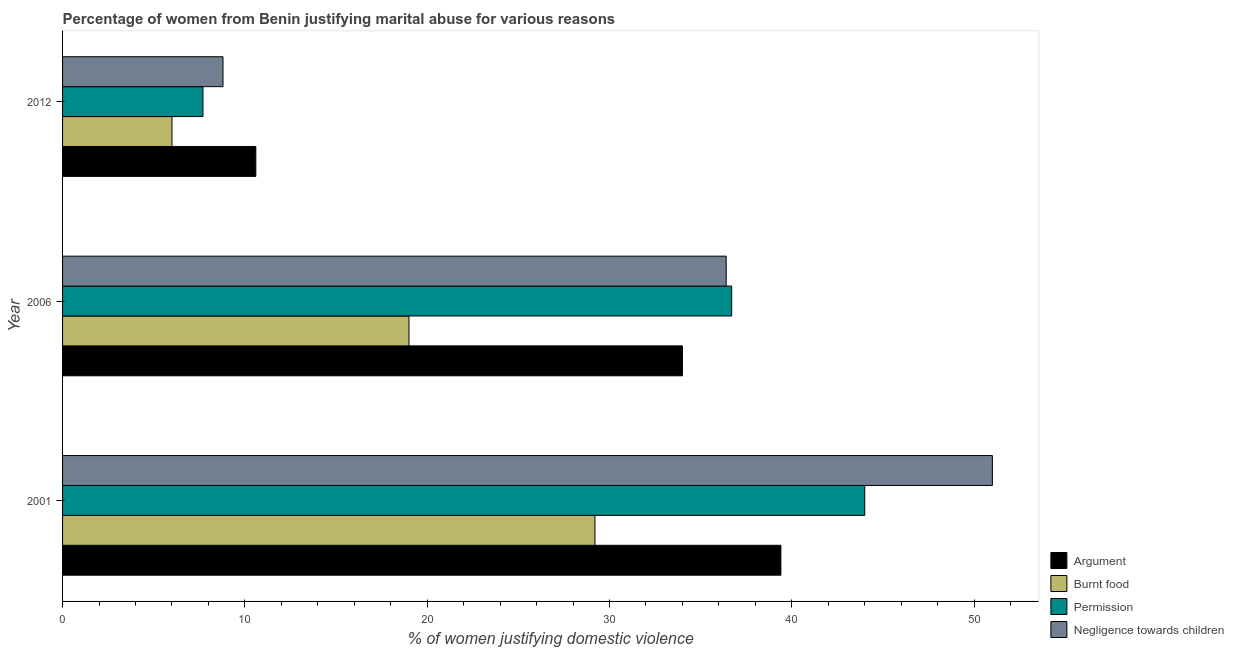How many different coloured bars are there?
Offer a terse response. 4. Are the number of bars on each tick of the Y-axis equal?
Ensure brevity in your answer.  Yes. How many bars are there on the 1st tick from the top?
Ensure brevity in your answer.  4. In how many cases, is the number of bars for a given year not equal to the number of legend labels?
Your response must be concise. 0. What is the percentage of women justifying abuse for going without permission in 2001?
Ensure brevity in your answer.  44. Across all years, what is the maximum percentage of women justifying abuse in the case of an argument?
Make the answer very short. 39.4. In which year was the percentage of women justifying abuse for showing negligence towards children minimum?
Keep it short and to the point. 2012. What is the total percentage of women justifying abuse for burning food in the graph?
Offer a terse response. 54.2. What is the difference between the percentage of women justifying abuse for going without permission in 2001 and that in 2012?
Provide a short and direct response. 36.3. What is the difference between the percentage of women justifying abuse for going without permission in 2001 and the percentage of women justifying abuse for showing negligence towards children in 2012?
Provide a short and direct response. 35.2. What is the average percentage of women justifying abuse for showing negligence towards children per year?
Your answer should be compact. 32.07. In how many years, is the percentage of women justifying abuse in the case of an argument greater than 38 %?
Provide a succinct answer. 1. What is the ratio of the percentage of women justifying abuse for burning food in 2001 to that in 2006?
Your response must be concise. 1.54. Is the difference between the percentage of women justifying abuse for going without permission in 2001 and 2012 greater than the difference between the percentage of women justifying abuse for burning food in 2001 and 2012?
Ensure brevity in your answer.  Yes. What is the difference between the highest and the lowest percentage of women justifying abuse for showing negligence towards children?
Your answer should be compact. 42.2. Is it the case that in every year, the sum of the percentage of women justifying abuse for going without permission and percentage of women justifying abuse in the case of an argument is greater than the sum of percentage of women justifying abuse for burning food and percentage of women justifying abuse for showing negligence towards children?
Provide a short and direct response. No. What does the 2nd bar from the top in 2012 represents?
Your response must be concise. Permission. What does the 2nd bar from the bottom in 2006 represents?
Your answer should be very brief. Burnt food. Is it the case that in every year, the sum of the percentage of women justifying abuse in the case of an argument and percentage of women justifying abuse for burning food is greater than the percentage of women justifying abuse for going without permission?
Keep it short and to the point. Yes. Are all the bars in the graph horizontal?
Keep it short and to the point. Yes. How many years are there in the graph?
Your answer should be compact. 3. What is the difference between two consecutive major ticks on the X-axis?
Offer a terse response. 10. Are the values on the major ticks of X-axis written in scientific E-notation?
Offer a terse response. No. Does the graph contain grids?
Keep it short and to the point. No. How many legend labels are there?
Provide a succinct answer. 4. What is the title of the graph?
Provide a short and direct response. Percentage of women from Benin justifying marital abuse for various reasons. Does "Overall level" appear as one of the legend labels in the graph?
Your response must be concise. No. What is the label or title of the X-axis?
Ensure brevity in your answer.  % of women justifying domestic violence. What is the % of women justifying domestic violence of Argument in 2001?
Ensure brevity in your answer.  39.4. What is the % of women justifying domestic violence in Burnt food in 2001?
Provide a short and direct response. 29.2. What is the % of women justifying domestic violence of Burnt food in 2006?
Ensure brevity in your answer.  19. What is the % of women justifying domestic violence of Permission in 2006?
Keep it short and to the point. 36.7. What is the % of women justifying domestic violence of Negligence towards children in 2006?
Your response must be concise. 36.4. What is the % of women justifying domestic violence of Permission in 2012?
Provide a succinct answer. 7.7. What is the % of women justifying domestic violence of Negligence towards children in 2012?
Make the answer very short. 8.8. Across all years, what is the maximum % of women justifying domestic violence in Argument?
Provide a succinct answer. 39.4. Across all years, what is the maximum % of women justifying domestic violence in Burnt food?
Keep it short and to the point. 29.2. Across all years, what is the maximum % of women justifying domestic violence in Permission?
Your response must be concise. 44. Across all years, what is the maximum % of women justifying domestic violence in Negligence towards children?
Offer a very short reply. 51. Across all years, what is the minimum % of women justifying domestic violence in Argument?
Offer a very short reply. 10.6. Across all years, what is the minimum % of women justifying domestic violence in Permission?
Provide a short and direct response. 7.7. Across all years, what is the minimum % of women justifying domestic violence of Negligence towards children?
Provide a short and direct response. 8.8. What is the total % of women justifying domestic violence of Burnt food in the graph?
Make the answer very short. 54.2. What is the total % of women justifying domestic violence of Permission in the graph?
Make the answer very short. 88.4. What is the total % of women justifying domestic violence in Negligence towards children in the graph?
Keep it short and to the point. 96.2. What is the difference between the % of women justifying domestic violence of Argument in 2001 and that in 2006?
Make the answer very short. 5.4. What is the difference between the % of women justifying domestic violence in Burnt food in 2001 and that in 2006?
Provide a succinct answer. 10.2. What is the difference between the % of women justifying domestic violence in Argument in 2001 and that in 2012?
Keep it short and to the point. 28.8. What is the difference between the % of women justifying domestic violence in Burnt food in 2001 and that in 2012?
Your response must be concise. 23.2. What is the difference between the % of women justifying domestic violence in Permission in 2001 and that in 2012?
Provide a short and direct response. 36.3. What is the difference between the % of women justifying domestic violence of Negligence towards children in 2001 and that in 2012?
Offer a very short reply. 42.2. What is the difference between the % of women justifying domestic violence of Argument in 2006 and that in 2012?
Keep it short and to the point. 23.4. What is the difference between the % of women justifying domestic violence in Burnt food in 2006 and that in 2012?
Your answer should be compact. 13. What is the difference between the % of women justifying domestic violence of Negligence towards children in 2006 and that in 2012?
Your response must be concise. 27.6. What is the difference between the % of women justifying domestic violence in Argument in 2001 and the % of women justifying domestic violence in Burnt food in 2006?
Keep it short and to the point. 20.4. What is the difference between the % of women justifying domestic violence of Argument in 2001 and the % of women justifying domestic violence of Permission in 2006?
Provide a succinct answer. 2.7. What is the difference between the % of women justifying domestic violence of Argument in 2001 and the % of women justifying domestic violence of Burnt food in 2012?
Your answer should be very brief. 33.4. What is the difference between the % of women justifying domestic violence in Argument in 2001 and the % of women justifying domestic violence in Permission in 2012?
Offer a very short reply. 31.7. What is the difference between the % of women justifying domestic violence of Argument in 2001 and the % of women justifying domestic violence of Negligence towards children in 2012?
Offer a terse response. 30.6. What is the difference between the % of women justifying domestic violence in Burnt food in 2001 and the % of women justifying domestic violence in Permission in 2012?
Your answer should be compact. 21.5. What is the difference between the % of women justifying domestic violence of Burnt food in 2001 and the % of women justifying domestic violence of Negligence towards children in 2012?
Your response must be concise. 20.4. What is the difference between the % of women justifying domestic violence of Permission in 2001 and the % of women justifying domestic violence of Negligence towards children in 2012?
Your answer should be very brief. 35.2. What is the difference between the % of women justifying domestic violence in Argument in 2006 and the % of women justifying domestic violence in Burnt food in 2012?
Provide a short and direct response. 28. What is the difference between the % of women justifying domestic violence in Argument in 2006 and the % of women justifying domestic violence in Permission in 2012?
Offer a terse response. 26.3. What is the difference between the % of women justifying domestic violence in Argument in 2006 and the % of women justifying domestic violence in Negligence towards children in 2012?
Your response must be concise. 25.2. What is the difference between the % of women justifying domestic violence in Permission in 2006 and the % of women justifying domestic violence in Negligence towards children in 2012?
Ensure brevity in your answer.  27.9. What is the average % of women justifying domestic violence of Burnt food per year?
Ensure brevity in your answer.  18.07. What is the average % of women justifying domestic violence in Permission per year?
Keep it short and to the point. 29.47. What is the average % of women justifying domestic violence in Negligence towards children per year?
Keep it short and to the point. 32.07. In the year 2001, what is the difference between the % of women justifying domestic violence in Argument and % of women justifying domestic violence in Negligence towards children?
Your answer should be compact. -11.6. In the year 2001, what is the difference between the % of women justifying domestic violence of Burnt food and % of women justifying domestic violence of Permission?
Make the answer very short. -14.8. In the year 2001, what is the difference between the % of women justifying domestic violence of Burnt food and % of women justifying domestic violence of Negligence towards children?
Offer a very short reply. -21.8. In the year 2001, what is the difference between the % of women justifying domestic violence of Permission and % of women justifying domestic violence of Negligence towards children?
Offer a terse response. -7. In the year 2006, what is the difference between the % of women justifying domestic violence in Argument and % of women justifying domestic violence in Negligence towards children?
Keep it short and to the point. -2.4. In the year 2006, what is the difference between the % of women justifying domestic violence of Burnt food and % of women justifying domestic violence of Permission?
Provide a short and direct response. -17.7. In the year 2006, what is the difference between the % of women justifying domestic violence of Burnt food and % of women justifying domestic violence of Negligence towards children?
Your answer should be compact. -17.4. In the year 2012, what is the difference between the % of women justifying domestic violence of Argument and % of women justifying domestic violence of Negligence towards children?
Provide a short and direct response. 1.8. In the year 2012, what is the difference between the % of women justifying domestic violence of Burnt food and % of women justifying domestic violence of Negligence towards children?
Make the answer very short. -2.8. In the year 2012, what is the difference between the % of women justifying domestic violence in Permission and % of women justifying domestic violence in Negligence towards children?
Offer a very short reply. -1.1. What is the ratio of the % of women justifying domestic violence in Argument in 2001 to that in 2006?
Your answer should be compact. 1.16. What is the ratio of the % of women justifying domestic violence of Burnt food in 2001 to that in 2006?
Offer a terse response. 1.54. What is the ratio of the % of women justifying domestic violence of Permission in 2001 to that in 2006?
Give a very brief answer. 1.2. What is the ratio of the % of women justifying domestic violence in Negligence towards children in 2001 to that in 2006?
Give a very brief answer. 1.4. What is the ratio of the % of women justifying domestic violence of Argument in 2001 to that in 2012?
Ensure brevity in your answer.  3.72. What is the ratio of the % of women justifying domestic violence in Burnt food in 2001 to that in 2012?
Provide a succinct answer. 4.87. What is the ratio of the % of women justifying domestic violence of Permission in 2001 to that in 2012?
Give a very brief answer. 5.71. What is the ratio of the % of women justifying domestic violence in Negligence towards children in 2001 to that in 2012?
Make the answer very short. 5.8. What is the ratio of the % of women justifying domestic violence of Argument in 2006 to that in 2012?
Give a very brief answer. 3.21. What is the ratio of the % of women justifying domestic violence in Burnt food in 2006 to that in 2012?
Offer a very short reply. 3.17. What is the ratio of the % of women justifying domestic violence in Permission in 2006 to that in 2012?
Provide a short and direct response. 4.77. What is the ratio of the % of women justifying domestic violence in Negligence towards children in 2006 to that in 2012?
Ensure brevity in your answer.  4.14. What is the difference between the highest and the lowest % of women justifying domestic violence in Argument?
Your answer should be compact. 28.8. What is the difference between the highest and the lowest % of women justifying domestic violence of Burnt food?
Offer a very short reply. 23.2. What is the difference between the highest and the lowest % of women justifying domestic violence in Permission?
Give a very brief answer. 36.3. What is the difference between the highest and the lowest % of women justifying domestic violence of Negligence towards children?
Offer a very short reply. 42.2. 